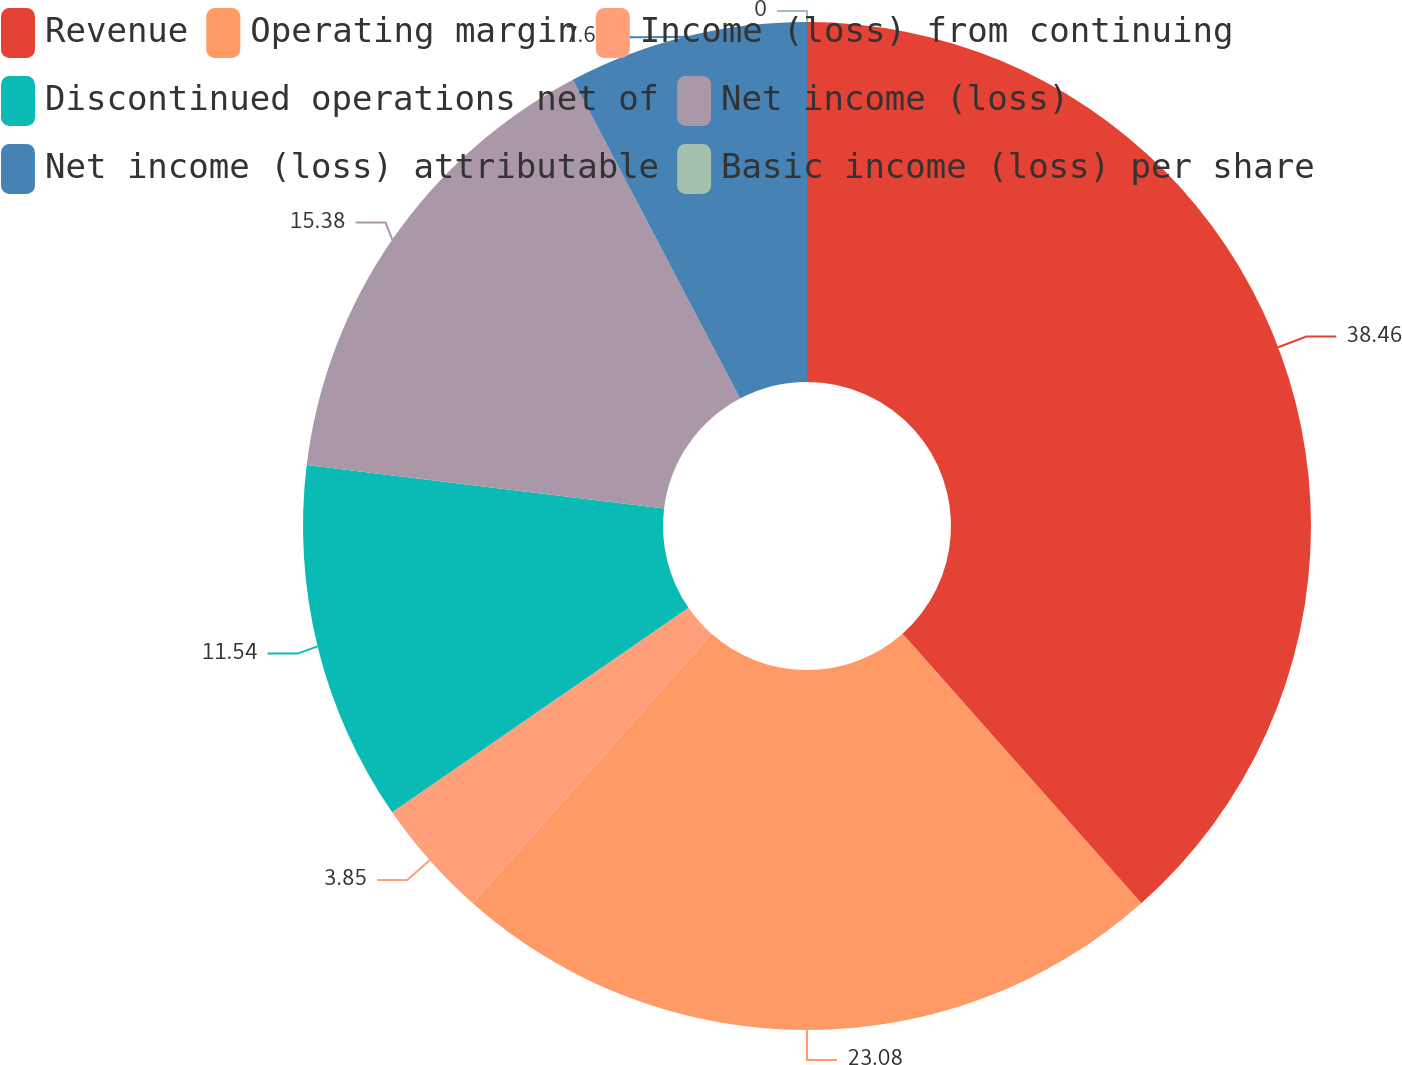<chart> <loc_0><loc_0><loc_500><loc_500><pie_chart><fcel>Revenue<fcel>Operating margin<fcel>Income (loss) from continuing<fcel>Discontinued operations net of<fcel>Net income (loss)<fcel>Net income (loss) attributable<fcel>Basic income (loss) per share<nl><fcel>38.46%<fcel>23.08%<fcel>3.85%<fcel>11.54%<fcel>15.38%<fcel>7.69%<fcel>0.0%<nl></chart> 